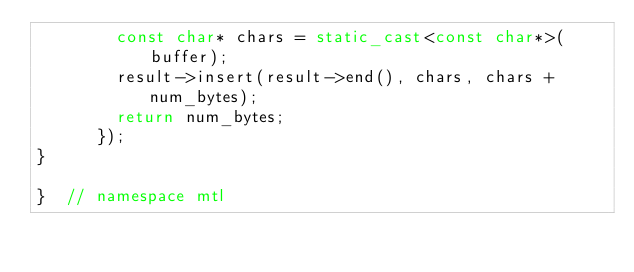Convert code to text. <code><loc_0><loc_0><loc_500><loc_500><_C++_>        const char* chars = static_cast<const char*>(buffer);
        result->insert(result->end(), chars, chars + num_bytes);
        return num_bytes;
      });
}

}  // namespace mtl
</code> 